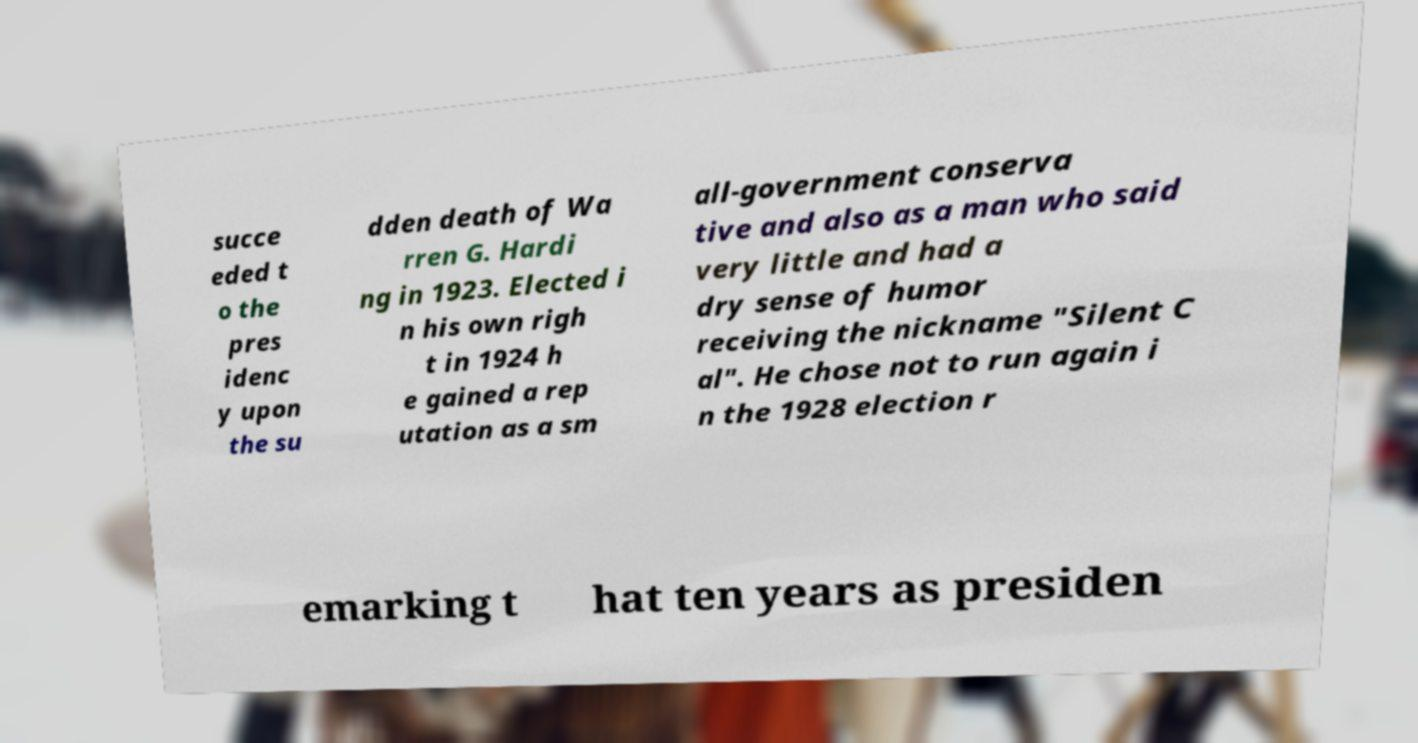For documentation purposes, I need the text within this image transcribed. Could you provide that? succe eded t o the pres idenc y upon the su dden death of Wa rren G. Hardi ng in 1923. Elected i n his own righ t in 1924 h e gained a rep utation as a sm all-government conserva tive and also as a man who said very little and had a dry sense of humor receiving the nickname "Silent C al". He chose not to run again i n the 1928 election r emarking t hat ten years as presiden 